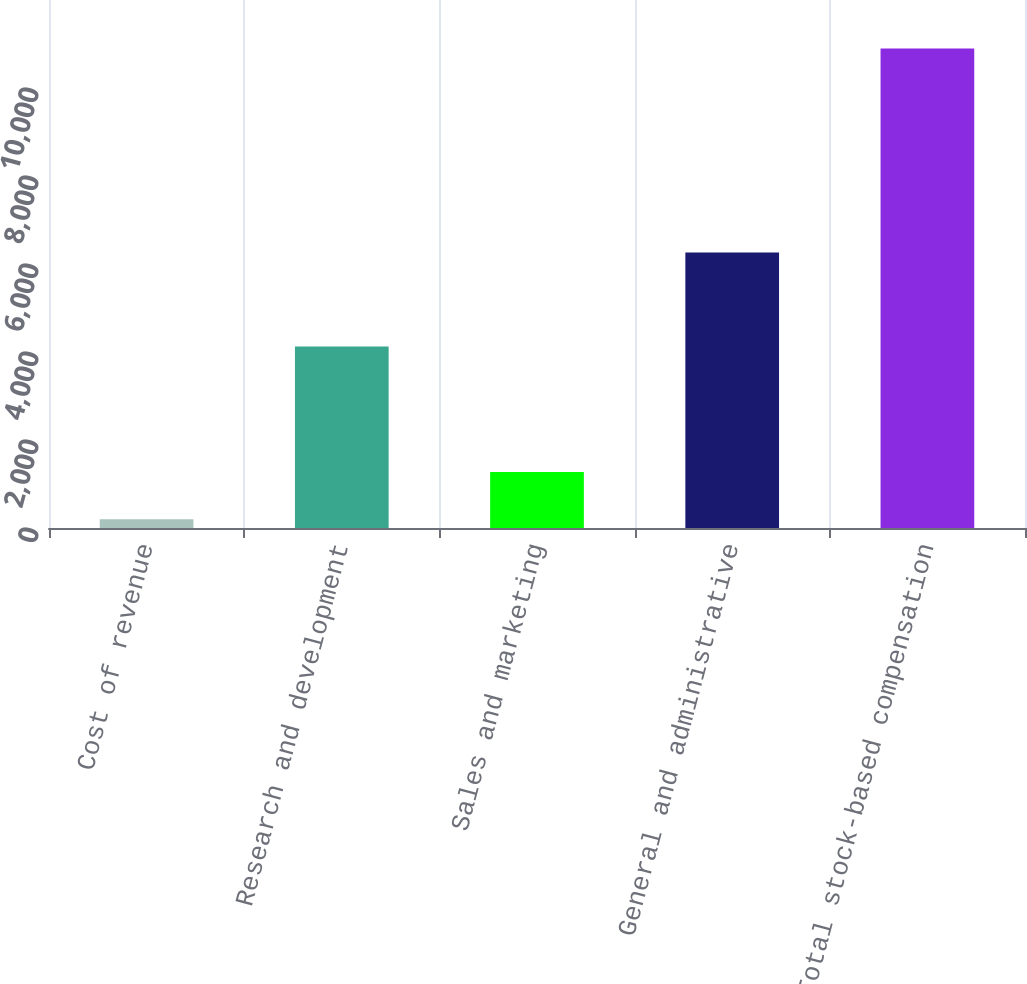<chart> <loc_0><loc_0><loc_500><loc_500><bar_chart><fcel>Cost of revenue<fcel>Research and development<fcel>Sales and marketing<fcel>General and administrative<fcel>Total stock-based compensation<nl><fcel>200<fcel>4126<fcel>1270<fcel>6261<fcel>10900<nl></chart> 